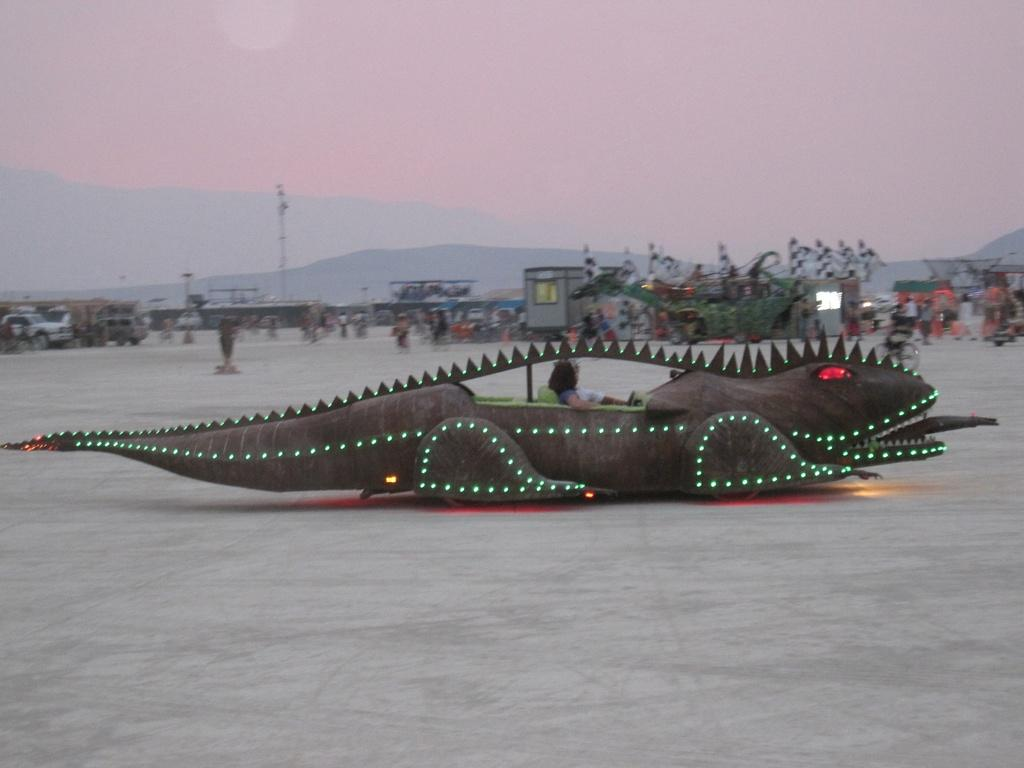What types of objects are present in the image? There are vehicles and buildings in the image. Are there any living beings in the image? Yes, there are people in the image. What can be seen at the top of the image? The sky is visible at the top of the image. What type of orange is being used as a prop in the image? There is no orange present in the image. What holiday is being celebrated in the image? There is no indication of a holiday being celebrated in the image. 